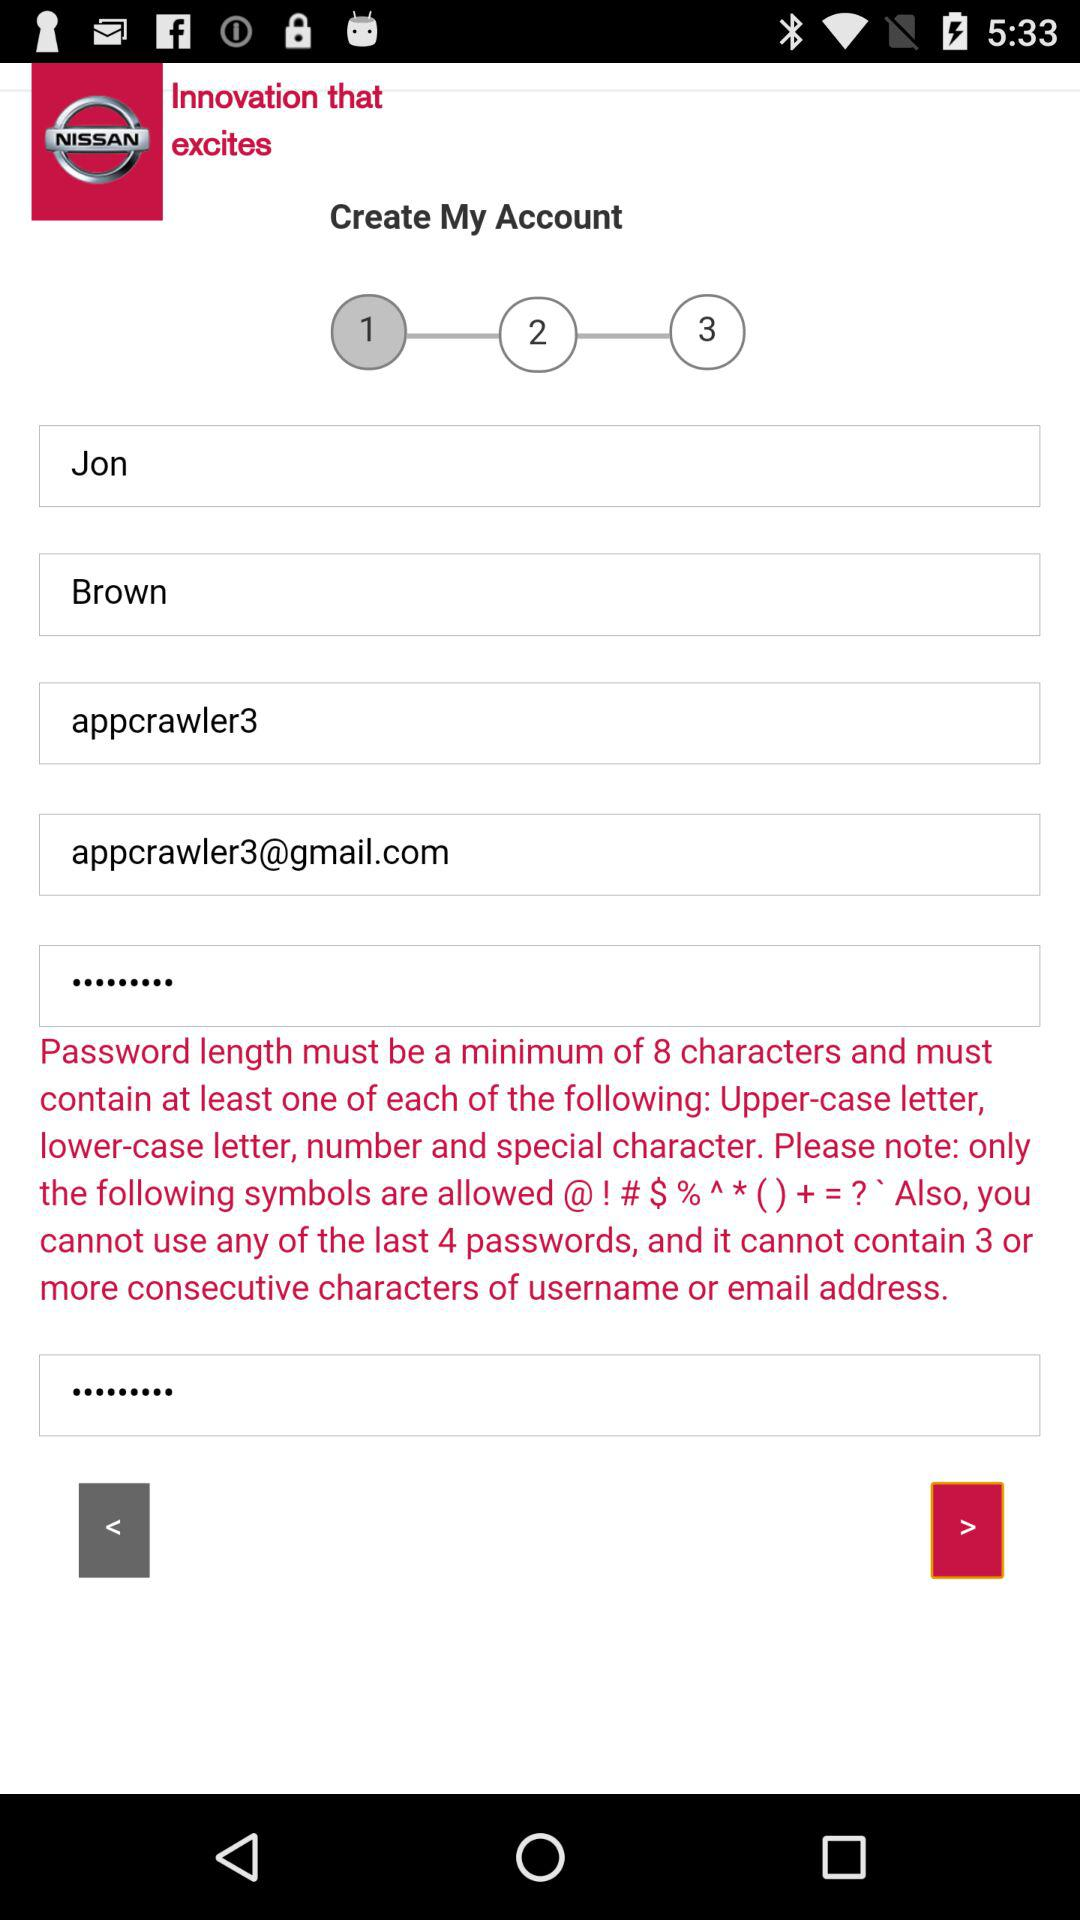What is the first name? The first name is Jon. 